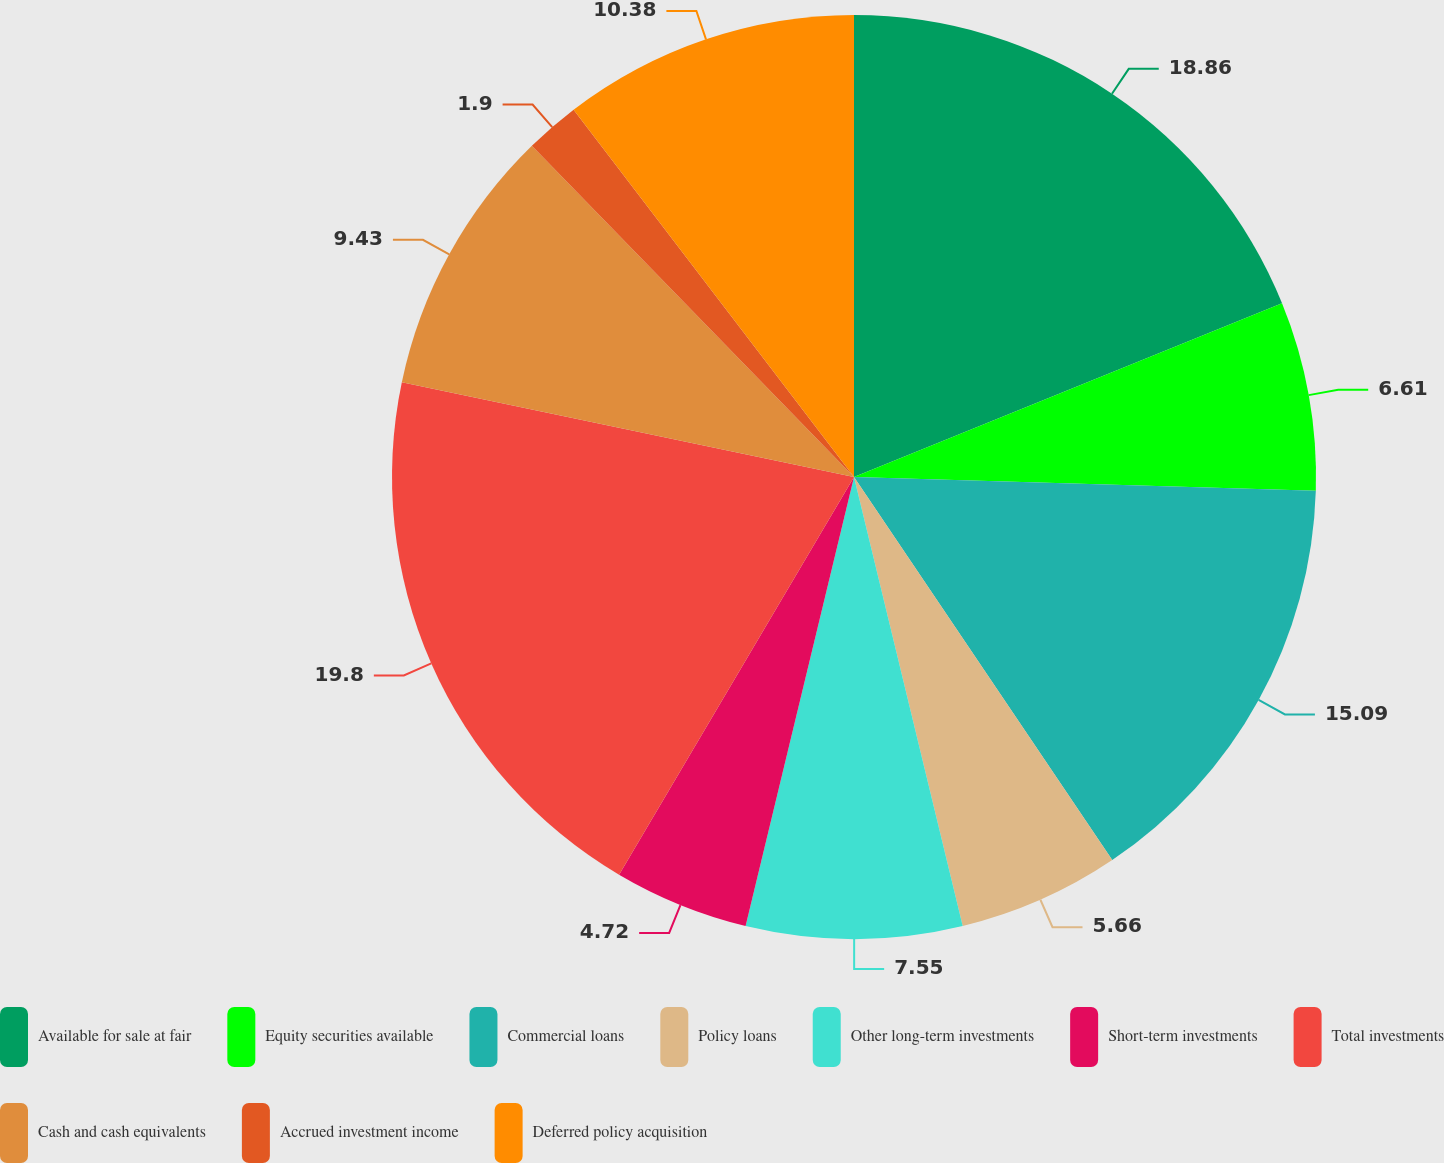Convert chart. <chart><loc_0><loc_0><loc_500><loc_500><pie_chart><fcel>Available for sale at fair<fcel>Equity securities available<fcel>Commercial loans<fcel>Policy loans<fcel>Other long-term investments<fcel>Short-term investments<fcel>Total investments<fcel>Cash and cash equivalents<fcel>Accrued investment income<fcel>Deferred policy acquisition<nl><fcel>18.86%<fcel>6.61%<fcel>15.09%<fcel>5.66%<fcel>7.55%<fcel>4.72%<fcel>19.8%<fcel>9.43%<fcel>1.9%<fcel>10.38%<nl></chart> 